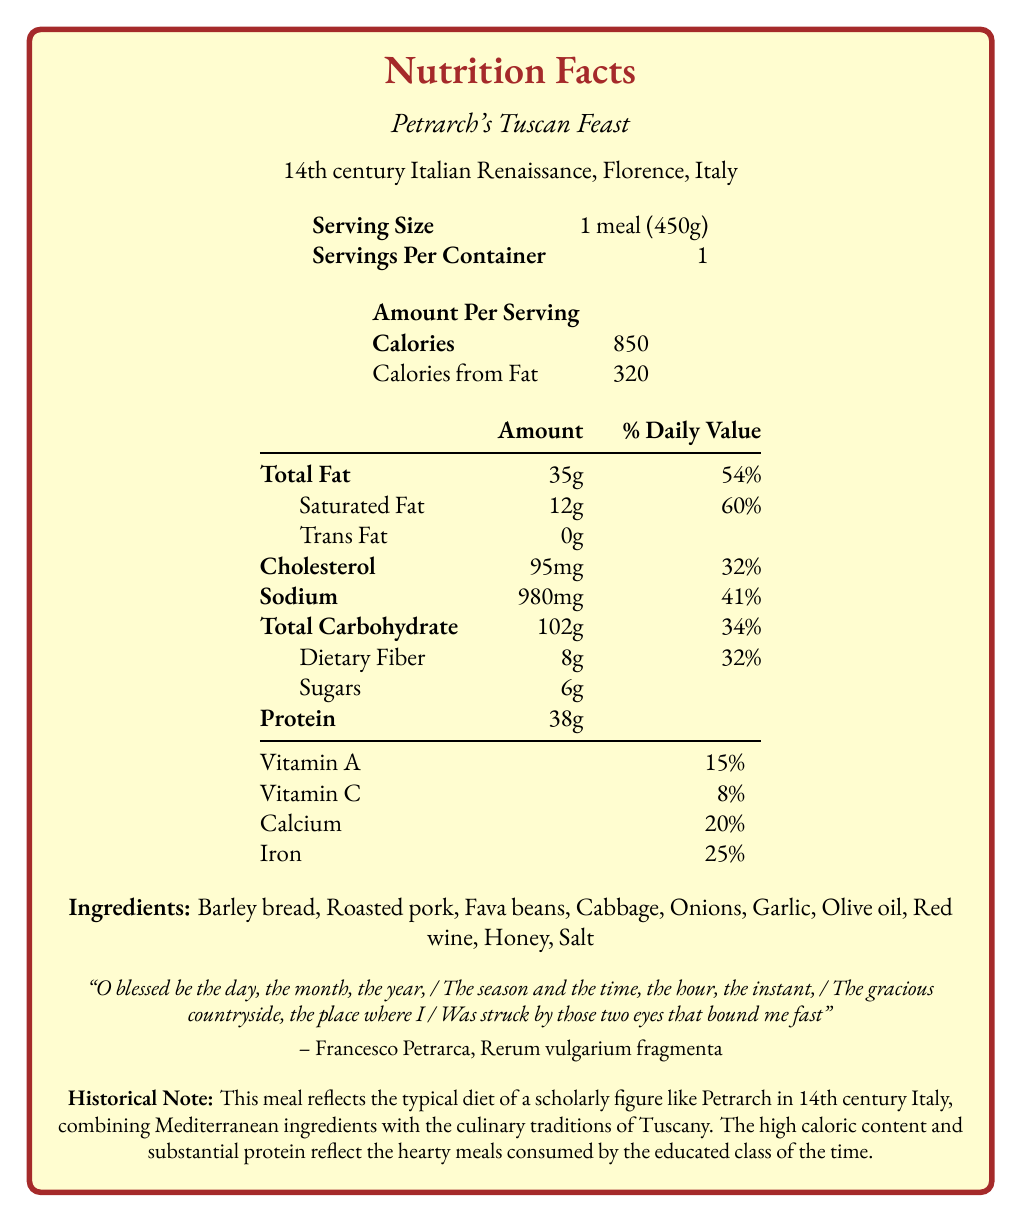what is the serving size of the meal? The serving size is listed as "1 meal (450g)" in the nutrition facts section.
Answer: 1 meal (450g) how many calories are in one serving of Petrarch's Tuscan Feast? The document states there are 850 calories in one serving of the meal.
Answer: 850 calories what percentage of the daily value is the saturated fat content in the meal? The nutrition facts label indicates that the saturated fat content is 12g, which is 60% of the daily value.
Answer: 60% how much sodium does the meal contain? The sodium content is listed as 980mg on the nutrition label.
Answer: 980mg how many grams of protein are in the meal? The nutrition facts state that the meal contains 38 grams of protein.
Answer: 38 grams which of the following is an ingredient in Petrarch's Tuscan Feast?
A. Peas
B. Garlic
C. Apples Garlic is listed as one of the ingredients in the meal.
Answer: B what is the percentage of daily value for iron provided by the meal?
A. 20%
B. 25%
C. 15% The meal provides 25% of the daily value for iron.
Answer: B Does the meal contain trans fat? The nutrition facts label indicates that the meal contains 0g of trans fat.
Answer: No Summarize the main idea of the document. This summary combines the key details from the nutrition facts, the meal's context, ingredients, and the historical note.
Answer: Petrarch's Tuscan Feast is a 14th-century Italian Renaissance meal attributed to the scholarly figure Francesco Petrarca. The meal, consisting of ingredients like barley bread and roasted pork, provides significant caloric content and macronutrients, reflective of the diet of educated people in that era. It is designed to be hearty and rich in protein. The document details the nutrition facts with emphasis on calories, fats, cholesterol, carbohydrates, and protein, as well as vitamins and minerals. What is the calorie content from fat in the meal? The document indicates that 320 calories come from fat.
Answer: 320 calories What is the relevance of the quote in the context of the meal? The quote from Francesco Petrarca's "Rerum vulgarium fragmenta" is included but its specific relevance to the meal's nutritional information cannot be determined from the document alone.
Answer: Cannot be determined 